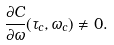Convert formula to latex. <formula><loc_0><loc_0><loc_500><loc_500>\frac { \partial C } { \partial \omega } ( \tau _ { c } , \omega _ { c } ) \neq 0 .</formula> 